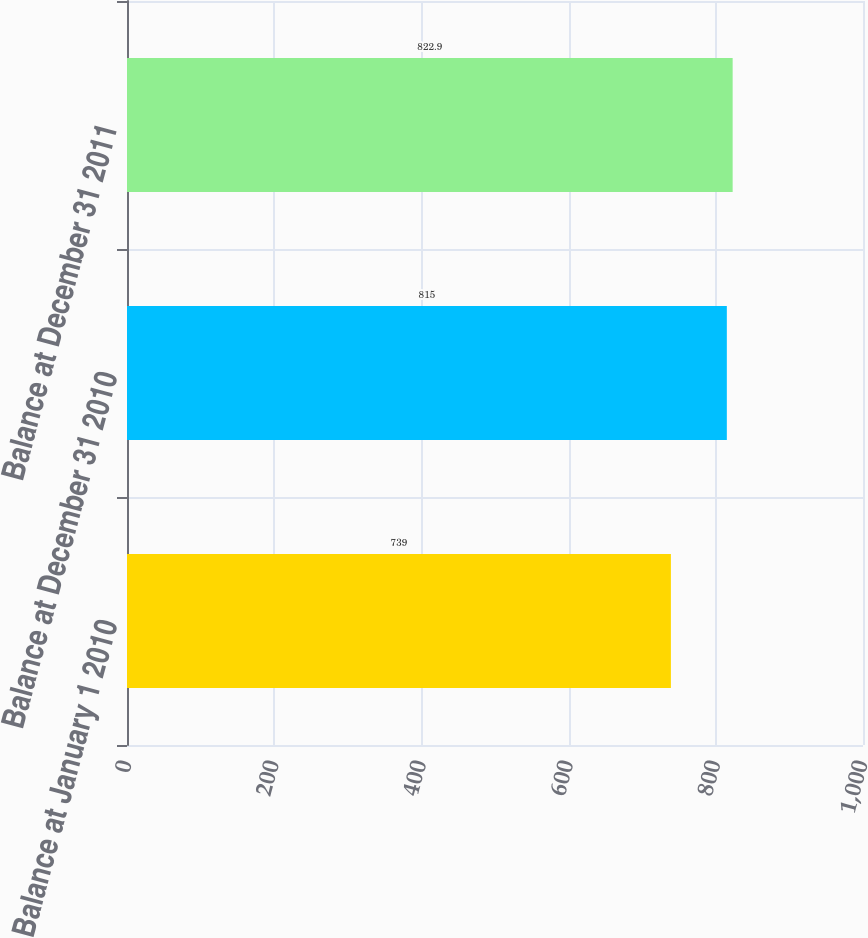Convert chart. <chart><loc_0><loc_0><loc_500><loc_500><bar_chart><fcel>Balance at January 1 2010<fcel>Balance at December 31 2010<fcel>Balance at December 31 2011<nl><fcel>739<fcel>815<fcel>822.9<nl></chart> 